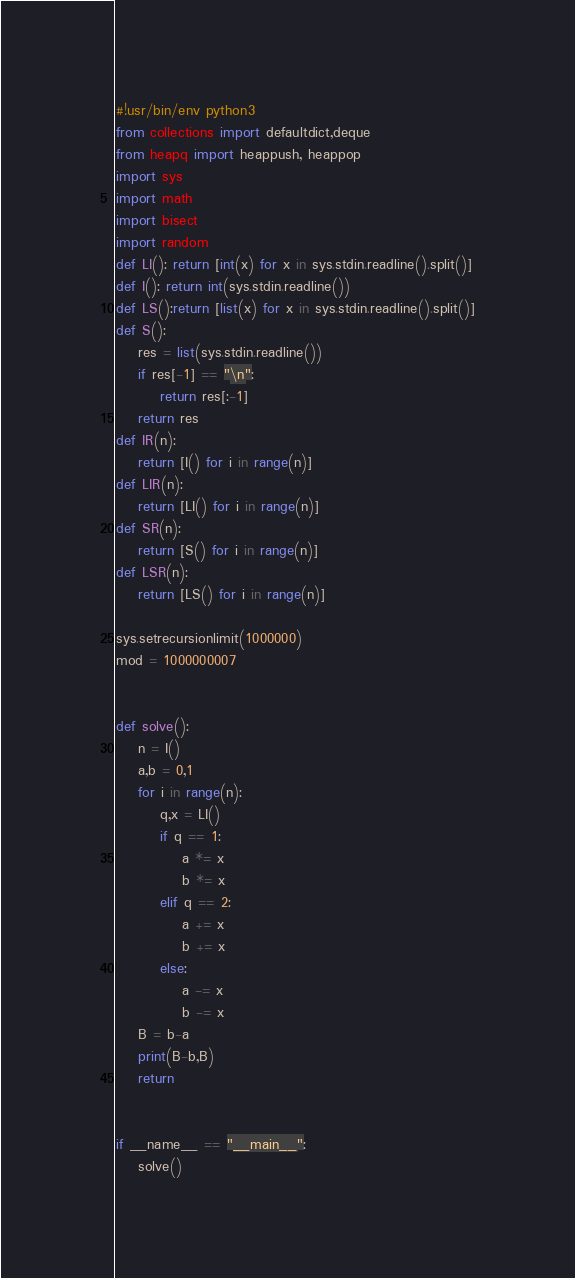<code> <loc_0><loc_0><loc_500><loc_500><_Python_>#!usr/bin/env python3
from collections import defaultdict,deque
from heapq import heappush, heappop
import sys
import math
import bisect
import random
def LI(): return [int(x) for x in sys.stdin.readline().split()]
def I(): return int(sys.stdin.readline())
def LS():return [list(x) for x in sys.stdin.readline().split()]
def S():
    res = list(sys.stdin.readline())
    if res[-1] == "\n":
        return res[:-1]
    return res
def IR(n):
    return [I() for i in range(n)]
def LIR(n):
    return [LI() for i in range(n)]
def SR(n):
    return [S() for i in range(n)]
def LSR(n):
    return [LS() for i in range(n)]

sys.setrecursionlimit(1000000)
mod = 1000000007


def solve():
    n = I()
    a,b = 0,1
    for i in range(n):
        q,x = LI()
        if q == 1:
            a *= x
            b *= x
        elif q == 2:
            a += x
            b += x
        else:
            a -= x
            b -= x
    B = b-a
    print(B-b,B)
    return


if __name__ == "__main__":
    solve()

</code> 